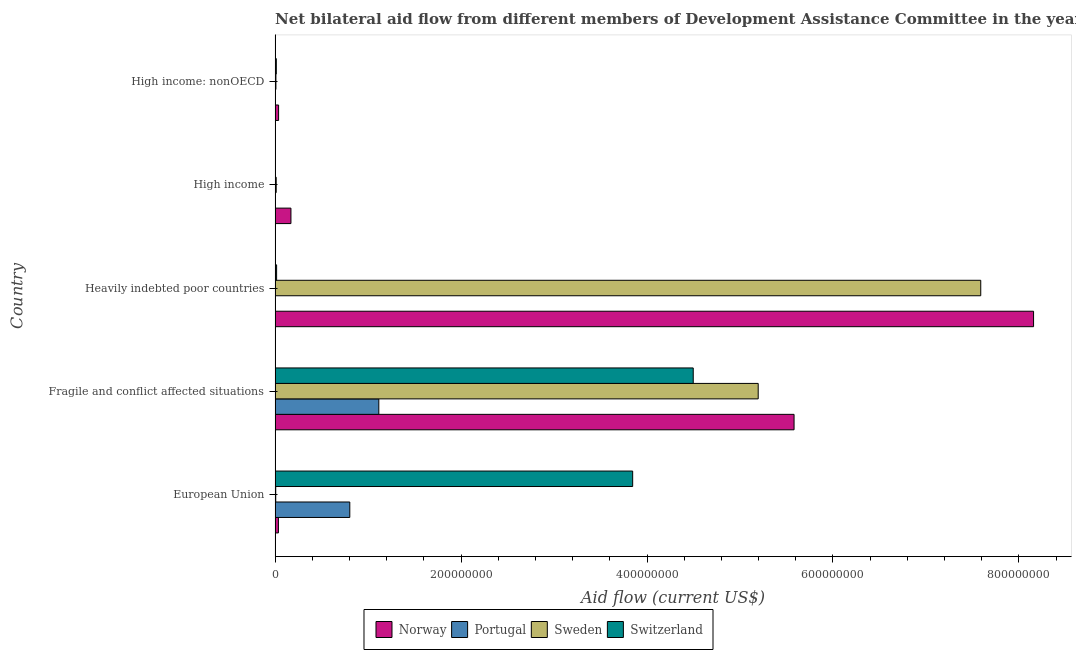How many different coloured bars are there?
Offer a terse response. 4. How many groups of bars are there?
Your answer should be very brief. 5. Are the number of bars per tick equal to the number of legend labels?
Your answer should be compact. Yes. How many bars are there on the 1st tick from the bottom?
Keep it short and to the point. 4. What is the label of the 1st group of bars from the top?
Your answer should be compact. High income: nonOECD. What is the amount of aid given by norway in European Union?
Offer a very short reply. 3.60e+06. Across all countries, what is the maximum amount of aid given by portugal?
Your response must be concise. 1.12e+08. Across all countries, what is the minimum amount of aid given by portugal?
Give a very brief answer. 9.00e+04. In which country was the amount of aid given by portugal maximum?
Offer a very short reply. Fragile and conflict affected situations. What is the total amount of aid given by sweden in the graph?
Ensure brevity in your answer.  1.28e+09. What is the difference between the amount of aid given by portugal in Heavily indebted poor countries and that in High income?
Provide a succinct answer. 9.00e+04. What is the difference between the amount of aid given by switzerland in Heavily indebted poor countries and the amount of aid given by sweden in High income: nonOECD?
Give a very brief answer. 7.40e+05. What is the average amount of aid given by switzerland per country?
Your response must be concise. 1.68e+08. What is the difference between the amount of aid given by portugal and amount of aid given by norway in European Union?
Offer a terse response. 7.68e+07. In how many countries, is the amount of aid given by norway greater than 640000000 US$?
Offer a terse response. 1. What is the ratio of the amount of aid given by switzerland in Heavily indebted poor countries to that in High income: nonOECD?
Make the answer very short. 1.23. Is the amount of aid given by switzerland in Heavily indebted poor countries less than that in High income?
Offer a terse response. No. Is the difference between the amount of aid given by sweden in Heavily indebted poor countries and High income greater than the difference between the amount of aid given by portugal in Heavily indebted poor countries and High income?
Make the answer very short. Yes. What is the difference between the highest and the second highest amount of aid given by norway?
Offer a very short reply. 2.58e+08. What is the difference between the highest and the lowest amount of aid given by portugal?
Offer a very short reply. 1.11e+08. Is the sum of the amount of aid given by switzerland in High income and High income: nonOECD greater than the maximum amount of aid given by sweden across all countries?
Your response must be concise. No. Is it the case that in every country, the sum of the amount of aid given by portugal and amount of aid given by norway is greater than the sum of amount of aid given by sweden and amount of aid given by switzerland?
Your response must be concise. Yes. What does the 1st bar from the top in High income: nonOECD represents?
Your answer should be compact. Switzerland. What does the 3rd bar from the bottom in High income represents?
Your answer should be very brief. Sweden. Is it the case that in every country, the sum of the amount of aid given by norway and amount of aid given by portugal is greater than the amount of aid given by sweden?
Give a very brief answer. Yes. How many bars are there?
Provide a short and direct response. 20. What is the difference between two consecutive major ticks on the X-axis?
Ensure brevity in your answer.  2.00e+08. Does the graph contain grids?
Your response must be concise. No. Where does the legend appear in the graph?
Provide a short and direct response. Bottom center. How many legend labels are there?
Ensure brevity in your answer.  4. How are the legend labels stacked?
Keep it short and to the point. Horizontal. What is the title of the graph?
Keep it short and to the point. Net bilateral aid flow from different members of Development Assistance Committee in the year 2009. What is the label or title of the X-axis?
Your response must be concise. Aid flow (current US$). What is the label or title of the Y-axis?
Offer a terse response. Country. What is the Aid flow (current US$) in Norway in European Union?
Provide a short and direct response. 3.60e+06. What is the Aid flow (current US$) of Portugal in European Union?
Your answer should be compact. 8.04e+07. What is the Aid flow (current US$) in Sweden in European Union?
Your answer should be compact. 7.10e+05. What is the Aid flow (current US$) of Switzerland in European Union?
Keep it short and to the point. 3.85e+08. What is the Aid flow (current US$) in Norway in Fragile and conflict affected situations?
Your answer should be compact. 5.58e+08. What is the Aid flow (current US$) in Portugal in Fragile and conflict affected situations?
Offer a very short reply. 1.12e+08. What is the Aid flow (current US$) of Sweden in Fragile and conflict affected situations?
Your answer should be very brief. 5.20e+08. What is the Aid flow (current US$) of Switzerland in Fragile and conflict affected situations?
Offer a very short reply. 4.50e+08. What is the Aid flow (current US$) of Norway in Heavily indebted poor countries?
Your response must be concise. 8.16e+08. What is the Aid flow (current US$) in Sweden in Heavily indebted poor countries?
Offer a terse response. 7.59e+08. What is the Aid flow (current US$) in Switzerland in Heavily indebted poor countries?
Ensure brevity in your answer.  1.64e+06. What is the Aid flow (current US$) of Norway in High income?
Keep it short and to the point. 1.71e+07. What is the Aid flow (current US$) of Portugal in High income?
Provide a succinct answer. 1.40e+05. What is the Aid flow (current US$) of Sweden in High income?
Your response must be concise. 1.20e+06. What is the Aid flow (current US$) in Norway in High income: nonOECD?
Provide a short and direct response. 3.78e+06. What is the Aid flow (current US$) of Portugal in High income: nonOECD?
Provide a succinct answer. 9.00e+04. What is the Aid flow (current US$) of Sweden in High income: nonOECD?
Make the answer very short. 9.00e+05. What is the Aid flow (current US$) of Switzerland in High income: nonOECD?
Offer a terse response. 1.33e+06. Across all countries, what is the maximum Aid flow (current US$) of Norway?
Provide a succinct answer. 8.16e+08. Across all countries, what is the maximum Aid flow (current US$) in Portugal?
Your answer should be compact. 1.12e+08. Across all countries, what is the maximum Aid flow (current US$) in Sweden?
Provide a succinct answer. 7.59e+08. Across all countries, what is the maximum Aid flow (current US$) in Switzerland?
Provide a short and direct response. 4.50e+08. Across all countries, what is the minimum Aid flow (current US$) of Norway?
Offer a terse response. 3.60e+06. Across all countries, what is the minimum Aid flow (current US$) of Portugal?
Give a very brief answer. 9.00e+04. Across all countries, what is the minimum Aid flow (current US$) of Sweden?
Give a very brief answer. 7.10e+05. What is the total Aid flow (current US$) of Norway in the graph?
Provide a short and direct response. 1.40e+09. What is the total Aid flow (current US$) of Portugal in the graph?
Your answer should be compact. 1.92e+08. What is the total Aid flow (current US$) of Sweden in the graph?
Your answer should be very brief. 1.28e+09. What is the total Aid flow (current US$) of Switzerland in the graph?
Make the answer very short. 8.38e+08. What is the difference between the Aid flow (current US$) of Norway in European Union and that in Fragile and conflict affected situations?
Your response must be concise. -5.55e+08. What is the difference between the Aid flow (current US$) of Portugal in European Union and that in Fragile and conflict affected situations?
Make the answer very short. -3.12e+07. What is the difference between the Aid flow (current US$) in Sweden in European Union and that in Fragile and conflict affected situations?
Offer a terse response. -5.19e+08. What is the difference between the Aid flow (current US$) in Switzerland in European Union and that in Fragile and conflict affected situations?
Your answer should be very brief. -6.51e+07. What is the difference between the Aid flow (current US$) of Norway in European Union and that in Heavily indebted poor countries?
Provide a short and direct response. -8.12e+08. What is the difference between the Aid flow (current US$) of Portugal in European Union and that in Heavily indebted poor countries?
Your answer should be compact. 8.01e+07. What is the difference between the Aid flow (current US$) of Sweden in European Union and that in Heavily indebted poor countries?
Make the answer very short. -7.58e+08. What is the difference between the Aid flow (current US$) in Switzerland in European Union and that in Heavily indebted poor countries?
Provide a succinct answer. 3.83e+08. What is the difference between the Aid flow (current US$) of Norway in European Union and that in High income?
Offer a very short reply. -1.35e+07. What is the difference between the Aid flow (current US$) of Portugal in European Union and that in High income?
Keep it short and to the point. 8.02e+07. What is the difference between the Aid flow (current US$) of Sweden in European Union and that in High income?
Keep it short and to the point. -4.90e+05. What is the difference between the Aid flow (current US$) in Switzerland in European Union and that in High income?
Your answer should be very brief. 3.84e+08. What is the difference between the Aid flow (current US$) of Portugal in European Union and that in High income: nonOECD?
Keep it short and to the point. 8.03e+07. What is the difference between the Aid flow (current US$) of Sweden in European Union and that in High income: nonOECD?
Your response must be concise. -1.90e+05. What is the difference between the Aid flow (current US$) of Switzerland in European Union and that in High income: nonOECD?
Offer a very short reply. 3.83e+08. What is the difference between the Aid flow (current US$) of Norway in Fragile and conflict affected situations and that in Heavily indebted poor countries?
Your answer should be very brief. -2.58e+08. What is the difference between the Aid flow (current US$) of Portugal in Fragile and conflict affected situations and that in Heavily indebted poor countries?
Offer a terse response. 1.11e+08. What is the difference between the Aid flow (current US$) in Sweden in Fragile and conflict affected situations and that in Heavily indebted poor countries?
Make the answer very short. -2.39e+08. What is the difference between the Aid flow (current US$) of Switzerland in Fragile and conflict affected situations and that in Heavily indebted poor countries?
Your answer should be very brief. 4.48e+08. What is the difference between the Aid flow (current US$) in Norway in Fragile and conflict affected situations and that in High income?
Offer a terse response. 5.41e+08. What is the difference between the Aid flow (current US$) in Portugal in Fragile and conflict affected situations and that in High income?
Make the answer very short. 1.11e+08. What is the difference between the Aid flow (current US$) of Sweden in Fragile and conflict affected situations and that in High income?
Offer a very short reply. 5.18e+08. What is the difference between the Aid flow (current US$) in Switzerland in Fragile and conflict affected situations and that in High income?
Give a very brief answer. 4.49e+08. What is the difference between the Aid flow (current US$) in Norway in Fragile and conflict affected situations and that in High income: nonOECD?
Keep it short and to the point. 5.54e+08. What is the difference between the Aid flow (current US$) of Portugal in Fragile and conflict affected situations and that in High income: nonOECD?
Provide a succinct answer. 1.11e+08. What is the difference between the Aid flow (current US$) in Sweden in Fragile and conflict affected situations and that in High income: nonOECD?
Your answer should be very brief. 5.19e+08. What is the difference between the Aid flow (current US$) of Switzerland in Fragile and conflict affected situations and that in High income: nonOECD?
Your response must be concise. 4.48e+08. What is the difference between the Aid flow (current US$) in Norway in Heavily indebted poor countries and that in High income?
Provide a short and direct response. 7.99e+08. What is the difference between the Aid flow (current US$) of Portugal in Heavily indebted poor countries and that in High income?
Ensure brevity in your answer.  9.00e+04. What is the difference between the Aid flow (current US$) of Sweden in Heavily indebted poor countries and that in High income?
Your response must be concise. 7.58e+08. What is the difference between the Aid flow (current US$) in Switzerland in Heavily indebted poor countries and that in High income?
Your response must be concise. 1.33e+06. What is the difference between the Aid flow (current US$) in Norway in Heavily indebted poor countries and that in High income: nonOECD?
Give a very brief answer. 8.12e+08. What is the difference between the Aid flow (current US$) of Portugal in Heavily indebted poor countries and that in High income: nonOECD?
Ensure brevity in your answer.  1.40e+05. What is the difference between the Aid flow (current US$) in Sweden in Heavily indebted poor countries and that in High income: nonOECD?
Keep it short and to the point. 7.58e+08. What is the difference between the Aid flow (current US$) of Switzerland in Heavily indebted poor countries and that in High income: nonOECD?
Give a very brief answer. 3.10e+05. What is the difference between the Aid flow (current US$) of Norway in High income and that in High income: nonOECD?
Give a very brief answer. 1.33e+07. What is the difference between the Aid flow (current US$) of Sweden in High income and that in High income: nonOECD?
Offer a very short reply. 3.00e+05. What is the difference between the Aid flow (current US$) of Switzerland in High income and that in High income: nonOECD?
Make the answer very short. -1.02e+06. What is the difference between the Aid flow (current US$) in Norway in European Union and the Aid flow (current US$) in Portugal in Fragile and conflict affected situations?
Make the answer very short. -1.08e+08. What is the difference between the Aid flow (current US$) of Norway in European Union and the Aid flow (current US$) of Sweden in Fragile and conflict affected situations?
Your answer should be very brief. -5.16e+08. What is the difference between the Aid flow (current US$) in Norway in European Union and the Aid flow (current US$) in Switzerland in Fragile and conflict affected situations?
Offer a terse response. -4.46e+08. What is the difference between the Aid flow (current US$) of Portugal in European Union and the Aid flow (current US$) of Sweden in Fragile and conflict affected situations?
Your response must be concise. -4.39e+08. What is the difference between the Aid flow (current US$) of Portugal in European Union and the Aid flow (current US$) of Switzerland in Fragile and conflict affected situations?
Provide a succinct answer. -3.69e+08. What is the difference between the Aid flow (current US$) of Sweden in European Union and the Aid flow (current US$) of Switzerland in Fragile and conflict affected situations?
Your answer should be compact. -4.49e+08. What is the difference between the Aid flow (current US$) in Norway in European Union and the Aid flow (current US$) in Portugal in Heavily indebted poor countries?
Provide a succinct answer. 3.37e+06. What is the difference between the Aid flow (current US$) in Norway in European Union and the Aid flow (current US$) in Sweden in Heavily indebted poor countries?
Give a very brief answer. -7.55e+08. What is the difference between the Aid flow (current US$) in Norway in European Union and the Aid flow (current US$) in Switzerland in Heavily indebted poor countries?
Ensure brevity in your answer.  1.96e+06. What is the difference between the Aid flow (current US$) of Portugal in European Union and the Aid flow (current US$) of Sweden in Heavily indebted poor countries?
Make the answer very short. -6.79e+08. What is the difference between the Aid flow (current US$) of Portugal in European Union and the Aid flow (current US$) of Switzerland in Heavily indebted poor countries?
Offer a very short reply. 7.87e+07. What is the difference between the Aid flow (current US$) of Sweden in European Union and the Aid flow (current US$) of Switzerland in Heavily indebted poor countries?
Provide a short and direct response. -9.30e+05. What is the difference between the Aid flow (current US$) of Norway in European Union and the Aid flow (current US$) of Portugal in High income?
Offer a terse response. 3.46e+06. What is the difference between the Aid flow (current US$) in Norway in European Union and the Aid flow (current US$) in Sweden in High income?
Give a very brief answer. 2.40e+06. What is the difference between the Aid flow (current US$) of Norway in European Union and the Aid flow (current US$) of Switzerland in High income?
Provide a short and direct response. 3.29e+06. What is the difference between the Aid flow (current US$) in Portugal in European Union and the Aid flow (current US$) in Sweden in High income?
Keep it short and to the point. 7.92e+07. What is the difference between the Aid flow (current US$) in Portugal in European Union and the Aid flow (current US$) in Switzerland in High income?
Your answer should be very brief. 8.00e+07. What is the difference between the Aid flow (current US$) in Norway in European Union and the Aid flow (current US$) in Portugal in High income: nonOECD?
Provide a short and direct response. 3.51e+06. What is the difference between the Aid flow (current US$) in Norway in European Union and the Aid flow (current US$) in Sweden in High income: nonOECD?
Ensure brevity in your answer.  2.70e+06. What is the difference between the Aid flow (current US$) of Norway in European Union and the Aid flow (current US$) of Switzerland in High income: nonOECD?
Ensure brevity in your answer.  2.27e+06. What is the difference between the Aid flow (current US$) of Portugal in European Union and the Aid flow (current US$) of Sweden in High income: nonOECD?
Provide a succinct answer. 7.95e+07. What is the difference between the Aid flow (current US$) of Portugal in European Union and the Aid flow (current US$) of Switzerland in High income: nonOECD?
Offer a terse response. 7.90e+07. What is the difference between the Aid flow (current US$) of Sweden in European Union and the Aid flow (current US$) of Switzerland in High income: nonOECD?
Give a very brief answer. -6.20e+05. What is the difference between the Aid flow (current US$) of Norway in Fragile and conflict affected situations and the Aid flow (current US$) of Portugal in Heavily indebted poor countries?
Your answer should be compact. 5.58e+08. What is the difference between the Aid flow (current US$) of Norway in Fragile and conflict affected situations and the Aid flow (current US$) of Sweden in Heavily indebted poor countries?
Your response must be concise. -2.01e+08. What is the difference between the Aid flow (current US$) in Norway in Fragile and conflict affected situations and the Aid flow (current US$) in Switzerland in Heavily indebted poor countries?
Provide a succinct answer. 5.57e+08. What is the difference between the Aid flow (current US$) of Portugal in Fragile and conflict affected situations and the Aid flow (current US$) of Sweden in Heavily indebted poor countries?
Ensure brevity in your answer.  -6.47e+08. What is the difference between the Aid flow (current US$) of Portugal in Fragile and conflict affected situations and the Aid flow (current US$) of Switzerland in Heavily indebted poor countries?
Provide a short and direct response. 1.10e+08. What is the difference between the Aid flow (current US$) of Sweden in Fragile and conflict affected situations and the Aid flow (current US$) of Switzerland in Heavily indebted poor countries?
Make the answer very short. 5.18e+08. What is the difference between the Aid flow (current US$) of Norway in Fragile and conflict affected situations and the Aid flow (current US$) of Portugal in High income?
Keep it short and to the point. 5.58e+08. What is the difference between the Aid flow (current US$) of Norway in Fragile and conflict affected situations and the Aid flow (current US$) of Sweden in High income?
Keep it short and to the point. 5.57e+08. What is the difference between the Aid flow (current US$) in Norway in Fragile and conflict affected situations and the Aid flow (current US$) in Switzerland in High income?
Provide a short and direct response. 5.58e+08. What is the difference between the Aid flow (current US$) in Portugal in Fragile and conflict affected situations and the Aid flow (current US$) in Sweden in High income?
Provide a short and direct response. 1.10e+08. What is the difference between the Aid flow (current US$) of Portugal in Fragile and conflict affected situations and the Aid flow (current US$) of Switzerland in High income?
Provide a short and direct response. 1.11e+08. What is the difference between the Aid flow (current US$) in Sweden in Fragile and conflict affected situations and the Aid flow (current US$) in Switzerland in High income?
Provide a succinct answer. 5.19e+08. What is the difference between the Aid flow (current US$) in Norway in Fragile and conflict affected situations and the Aid flow (current US$) in Portugal in High income: nonOECD?
Ensure brevity in your answer.  5.58e+08. What is the difference between the Aid flow (current US$) of Norway in Fragile and conflict affected situations and the Aid flow (current US$) of Sweden in High income: nonOECD?
Your answer should be compact. 5.57e+08. What is the difference between the Aid flow (current US$) in Norway in Fragile and conflict affected situations and the Aid flow (current US$) in Switzerland in High income: nonOECD?
Make the answer very short. 5.57e+08. What is the difference between the Aid flow (current US$) of Portugal in Fragile and conflict affected situations and the Aid flow (current US$) of Sweden in High income: nonOECD?
Provide a short and direct response. 1.11e+08. What is the difference between the Aid flow (current US$) of Portugal in Fragile and conflict affected situations and the Aid flow (current US$) of Switzerland in High income: nonOECD?
Your answer should be compact. 1.10e+08. What is the difference between the Aid flow (current US$) in Sweden in Fragile and conflict affected situations and the Aid flow (current US$) in Switzerland in High income: nonOECD?
Offer a terse response. 5.18e+08. What is the difference between the Aid flow (current US$) of Norway in Heavily indebted poor countries and the Aid flow (current US$) of Portugal in High income?
Your response must be concise. 8.16e+08. What is the difference between the Aid flow (current US$) of Norway in Heavily indebted poor countries and the Aid flow (current US$) of Sweden in High income?
Ensure brevity in your answer.  8.15e+08. What is the difference between the Aid flow (current US$) of Norway in Heavily indebted poor countries and the Aid flow (current US$) of Switzerland in High income?
Keep it short and to the point. 8.15e+08. What is the difference between the Aid flow (current US$) of Portugal in Heavily indebted poor countries and the Aid flow (current US$) of Sweden in High income?
Give a very brief answer. -9.70e+05. What is the difference between the Aid flow (current US$) of Portugal in Heavily indebted poor countries and the Aid flow (current US$) of Switzerland in High income?
Offer a terse response. -8.00e+04. What is the difference between the Aid flow (current US$) in Sweden in Heavily indebted poor countries and the Aid flow (current US$) in Switzerland in High income?
Offer a very short reply. 7.59e+08. What is the difference between the Aid flow (current US$) of Norway in Heavily indebted poor countries and the Aid flow (current US$) of Portugal in High income: nonOECD?
Ensure brevity in your answer.  8.16e+08. What is the difference between the Aid flow (current US$) in Norway in Heavily indebted poor countries and the Aid flow (current US$) in Sweden in High income: nonOECD?
Ensure brevity in your answer.  8.15e+08. What is the difference between the Aid flow (current US$) of Norway in Heavily indebted poor countries and the Aid flow (current US$) of Switzerland in High income: nonOECD?
Your answer should be very brief. 8.14e+08. What is the difference between the Aid flow (current US$) in Portugal in Heavily indebted poor countries and the Aid flow (current US$) in Sweden in High income: nonOECD?
Keep it short and to the point. -6.70e+05. What is the difference between the Aid flow (current US$) of Portugal in Heavily indebted poor countries and the Aid flow (current US$) of Switzerland in High income: nonOECD?
Provide a short and direct response. -1.10e+06. What is the difference between the Aid flow (current US$) of Sweden in Heavily indebted poor countries and the Aid flow (current US$) of Switzerland in High income: nonOECD?
Offer a very short reply. 7.58e+08. What is the difference between the Aid flow (current US$) in Norway in High income and the Aid flow (current US$) in Portugal in High income: nonOECD?
Make the answer very short. 1.70e+07. What is the difference between the Aid flow (current US$) of Norway in High income and the Aid flow (current US$) of Sweden in High income: nonOECD?
Provide a short and direct response. 1.62e+07. What is the difference between the Aid flow (current US$) in Norway in High income and the Aid flow (current US$) in Switzerland in High income: nonOECD?
Make the answer very short. 1.57e+07. What is the difference between the Aid flow (current US$) in Portugal in High income and the Aid flow (current US$) in Sweden in High income: nonOECD?
Make the answer very short. -7.60e+05. What is the difference between the Aid flow (current US$) of Portugal in High income and the Aid flow (current US$) of Switzerland in High income: nonOECD?
Offer a very short reply. -1.19e+06. What is the average Aid flow (current US$) in Norway per country?
Offer a very short reply. 2.80e+08. What is the average Aid flow (current US$) of Portugal per country?
Offer a very short reply. 3.85e+07. What is the average Aid flow (current US$) in Sweden per country?
Keep it short and to the point. 2.56e+08. What is the average Aid flow (current US$) in Switzerland per country?
Your response must be concise. 1.68e+08. What is the difference between the Aid flow (current US$) of Norway and Aid flow (current US$) of Portugal in European Union?
Provide a succinct answer. -7.68e+07. What is the difference between the Aid flow (current US$) of Norway and Aid flow (current US$) of Sweden in European Union?
Make the answer very short. 2.89e+06. What is the difference between the Aid flow (current US$) of Norway and Aid flow (current US$) of Switzerland in European Union?
Provide a succinct answer. -3.81e+08. What is the difference between the Aid flow (current US$) of Portugal and Aid flow (current US$) of Sweden in European Union?
Give a very brief answer. 7.96e+07. What is the difference between the Aid flow (current US$) in Portugal and Aid flow (current US$) in Switzerland in European Union?
Offer a terse response. -3.04e+08. What is the difference between the Aid flow (current US$) in Sweden and Aid flow (current US$) in Switzerland in European Union?
Give a very brief answer. -3.84e+08. What is the difference between the Aid flow (current US$) in Norway and Aid flow (current US$) in Portugal in Fragile and conflict affected situations?
Your response must be concise. 4.47e+08. What is the difference between the Aid flow (current US$) of Norway and Aid flow (current US$) of Sweden in Fragile and conflict affected situations?
Give a very brief answer. 3.86e+07. What is the difference between the Aid flow (current US$) in Norway and Aid flow (current US$) in Switzerland in Fragile and conflict affected situations?
Provide a succinct answer. 1.08e+08. What is the difference between the Aid flow (current US$) of Portugal and Aid flow (current US$) of Sweden in Fragile and conflict affected situations?
Make the answer very short. -4.08e+08. What is the difference between the Aid flow (current US$) in Portugal and Aid flow (current US$) in Switzerland in Fragile and conflict affected situations?
Ensure brevity in your answer.  -3.38e+08. What is the difference between the Aid flow (current US$) in Sweden and Aid flow (current US$) in Switzerland in Fragile and conflict affected situations?
Make the answer very short. 6.99e+07. What is the difference between the Aid flow (current US$) in Norway and Aid flow (current US$) in Portugal in Heavily indebted poor countries?
Provide a short and direct response. 8.16e+08. What is the difference between the Aid flow (current US$) in Norway and Aid flow (current US$) in Sweden in Heavily indebted poor countries?
Provide a succinct answer. 5.68e+07. What is the difference between the Aid flow (current US$) in Norway and Aid flow (current US$) in Switzerland in Heavily indebted poor countries?
Your response must be concise. 8.14e+08. What is the difference between the Aid flow (current US$) of Portugal and Aid flow (current US$) of Sweden in Heavily indebted poor countries?
Ensure brevity in your answer.  -7.59e+08. What is the difference between the Aid flow (current US$) in Portugal and Aid flow (current US$) in Switzerland in Heavily indebted poor countries?
Provide a short and direct response. -1.41e+06. What is the difference between the Aid flow (current US$) of Sweden and Aid flow (current US$) of Switzerland in Heavily indebted poor countries?
Your answer should be very brief. 7.57e+08. What is the difference between the Aid flow (current US$) of Norway and Aid flow (current US$) of Portugal in High income?
Your answer should be very brief. 1.69e+07. What is the difference between the Aid flow (current US$) of Norway and Aid flow (current US$) of Sweden in High income?
Give a very brief answer. 1.59e+07. What is the difference between the Aid flow (current US$) in Norway and Aid flow (current US$) in Switzerland in High income?
Offer a very short reply. 1.68e+07. What is the difference between the Aid flow (current US$) of Portugal and Aid flow (current US$) of Sweden in High income?
Ensure brevity in your answer.  -1.06e+06. What is the difference between the Aid flow (current US$) in Portugal and Aid flow (current US$) in Switzerland in High income?
Offer a terse response. -1.70e+05. What is the difference between the Aid flow (current US$) in Sweden and Aid flow (current US$) in Switzerland in High income?
Offer a terse response. 8.90e+05. What is the difference between the Aid flow (current US$) of Norway and Aid flow (current US$) of Portugal in High income: nonOECD?
Provide a short and direct response. 3.69e+06. What is the difference between the Aid flow (current US$) of Norway and Aid flow (current US$) of Sweden in High income: nonOECD?
Offer a very short reply. 2.88e+06. What is the difference between the Aid flow (current US$) in Norway and Aid flow (current US$) in Switzerland in High income: nonOECD?
Your answer should be compact. 2.45e+06. What is the difference between the Aid flow (current US$) of Portugal and Aid flow (current US$) of Sweden in High income: nonOECD?
Give a very brief answer. -8.10e+05. What is the difference between the Aid flow (current US$) of Portugal and Aid flow (current US$) of Switzerland in High income: nonOECD?
Make the answer very short. -1.24e+06. What is the difference between the Aid flow (current US$) of Sweden and Aid flow (current US$) of Switzerland in High income: nonOECD?
Offer a terse response. -4.30e+05. What is the ratio of the Aid flow (current US$) in Norway in European Union to that in Fragile and conflict affected situations?
Your answer should be very brief. 0.01. What is the ratio of the Aid flow (current US$) in Portugal in European Union to that in Fragile and conflict affected situations?
Provide a succinct answer. 0.72. What is the ratio of the Aid flow (current US$) of Sweden in European Union to that in Fragile and conflict affected situations?
Keep it short and to the point. 0. What is the ratio of the Aid flow (current US$) of Switzerland in European Union to that in Fragile and conflict affected situations?
Give a very brief answer. 0.86. What is the ratio of the Aid flow (current US$) of Norway in European Union to that in Heavily indebted poor countries?
Offer a terse response. 0. What is the ratio of the Aid flow (current US$) of Portugal in European Union to that in Heavily indebted poor countries?
Keep it short and to the point. 349.39. What is the ratio of the Aid flow (current US$) of Sweden in European Union to that in Heavily indebted poor countries?
Keep it short and to the point. 0. What is the ratio of the Aid flow (current US$) in Switzerland in European Union to that in Heavily indebted poor countries?
Your answer should be compact. 234.51. What is the ratio of the Aid flow (current US$) in Norway in European Union to that in High income?
Your response must be concise. 0.21. What is the ratio of the Aid flow (current US$) in Portugal in European Union to that in High income?
Your answer should be compact. 574. What is the ratio of the Aid flow (current US$) of Sweden in European Union to that in High income?
Ensure brevity in your answer.  0.59. What is the ratio of the Aid flow (current US$) in Switzerland in European Union to that in High income?
Give a very brief answer. 1240.61. What is the ratio of the Aid flow (current US$) of Portugal in European Union to that in High income: nonOECD?
Provide a succinct answer. 892.89. What is the ratio of the Aid flow (current US$) in Sweden in European Union to that in High income: nonOECD?
Your answer should be compact. 0.79. What is the ratio of the Aid flow (current US$) in Switzerland in European Union to that in High income: nonOECD?
Offer a terse response. 289.17. What is the ratio of the Aid flow (current US$) of Norway in Fragile and conflict affected situations to that in Heavily indebted poor countries?
Ensure brevity in your answer.  0.68. What is the ratio of the Aid flow (current US$) in Portugal in Fragile and conflict affected situations to that in Heavily indebted poor countries?
Keep it short and to the point. 485.04. What is the ratio of the Aid flow (current US$) in Sweden in Fragile and conflict affected situations to that in Heavily indebted poor countries?
Offer a terse response. 0.68. What is the ratio of the Aid flow (current US$) in Switzerland in Fragile and conflict affected situations to that in Heavily indebted poor countries?
Provide a succinct answer. 274.21. What is the ratio of the Aid flow (current US$) of Norway in Fragile and conflict affected situations to that in High income?
Offer a terse response. 32.72. What is the ratio of the Aid flow (current US$) of Portugal in Fragile and conflict affected situations to that in High income?
Offer a very short reply. 796.86. What is the ratio of the Aid flow (current US$) of Sweden in Fragile and conflict affected situations to that in High income?
Your answer should be compact. 432.99. What is the ratio of the Aid flow (current US$) in Switzerland in Fragile and conflict affected situations to that in High income?
Give a very brief answer. 1450.68. What is the ratio of the Aid flow (current US$) in Norway in Fragile and conflict affected situations to that in High income: nonOECD?
Offer a very short reply. 147.66. What is the ratio of the Aid flow (current US$) in Portugal in Fragile and conflict affected situations to that in High income: nonOECD?
Provide a short and direct response. 1239.56. What is the ratio of the Aid flow (current US$) of Sweden in Fragile and conflict affected situations to that in High income: nonOECD?
Give a very brief answer. 577.32. What is the ratio of the Aid flow (current US$) of Switzerland in Fragile and conflict affected situations to that in High income: nonOECD?
Your answer should be very brief. 338.13. What is the ratio of the Aid flow (current US$) of Norway in Heavily indebted poor countries to that in High income?
Make the answer very short. 47.82. What is the ratio of the Aid flow (current US$) in Portugal in Heavily indebted poor countries to that in High income?
Give a very brief answer. 1.64. What is the ratio of the Aid flow (current US$) in Sweden in Heavily indebted poor countries to that in High income?
Provide a succinct answer. 632.44. What is the ratio of the Aid flow (current US$) in Switzerland in Heavily indebted poor countries to that in High income?
Your answer should be very brief. 5.29. What is the ratio of the Aid flow (current US$) in Norway in Heavily indebted poor countries to that in High income: nonOECD?
Offer a very short reply. 215.8. What is the ratio of the Aid flow (current US$) of Portugal in Heavily indebted poor countries to that in High income: nonOECD?
Ensure brevity in your answer.  2.56. What is the ratio of the Aid flow (current US$) in Sweden in Heavily indebted poor countries to that in High income: nonOECD?
Offer a terse response. 843.26. What is the ratio of the Aid flow (current US$) of Switzerland in Heavily indebted poor countries to that in High income: nonOECD?
Your response must be concise. 1.23. What is the ratio of the Aid flow (current US$) in Norway in High income to that in High income: nonOECD?
Offer a terse response. 4.51. What is the ratio of the Aid flow (current US$) of Portugal in High income to that in High income: nonOECD?
Offer a very short reply. 1.56. What is the ratio of the Aid flow (current US$) of Sweden in High income to that in High income: nonOECD?
Offer a terse response. 1.33. What is the ratio of the Aid flow (current US$) of Switzerland in High income to that in High income: nonOECD?
Your response must be concise. 0.23. What is the difference between the highest and the second highest Aid flow (current US$) of Norway?
Keep it short and to the point. 2.58e+08. What is the difference between the highest and the second highest Aid flow (current US$) in Portugal?
Make the answer very short. 3.12e+07. What is the difference between the highest and the second highest Aid flow (current US$) of Sweden?
Provide a succinct answer. 2.39e+08. What is the difference between the highest and the second highest Aid flow (current US$) of Switzerland?
Your answer should be very brief. 6.51e+07. What is the difference between the highest and the lowest Aid flow (current US$) of Norway?
Ensure brevity in your answer.  8.12e+08. What is the difference between the highest and the lowest Aid flow (current US$) in Portugal?
Provide a succinct answer. 1.11e+08. What is the difference between the highest and the lowest Aid flow (current US$) in Sweden?
Your answer should be very brief. 7.58e+08. What is the difference between the highest and the lowest Aid flow (current US$) of Switzerland?
Make the answer very short. 4.49e+08. 